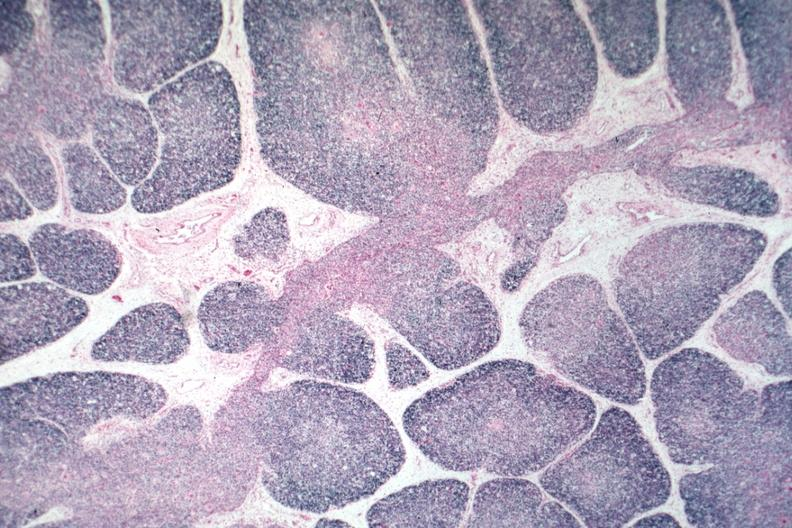what is present?
Answer the question using a single word or phrase. Thymus 